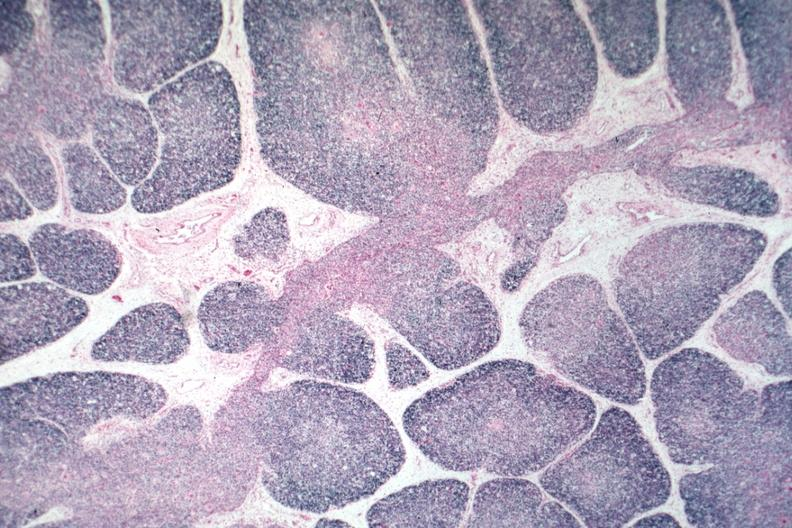what is present?
Answer the question using a single word or phrase. Thymus 